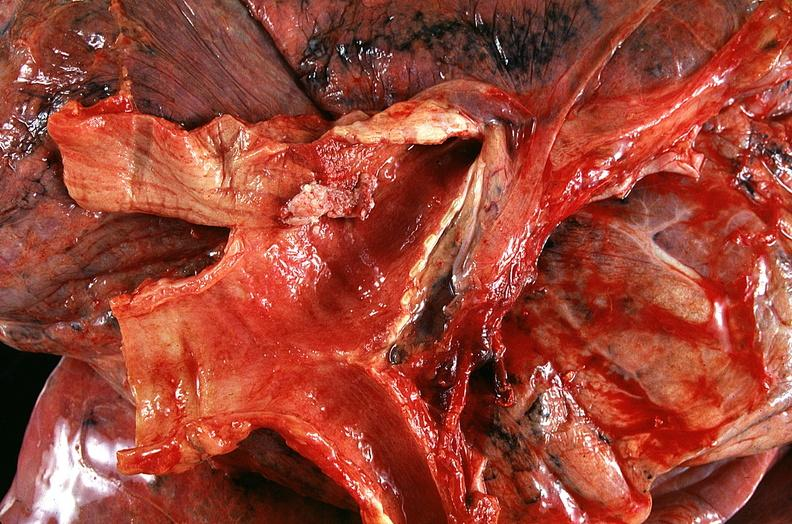where is this?
Answer the question using a single word or phrase. Lung 